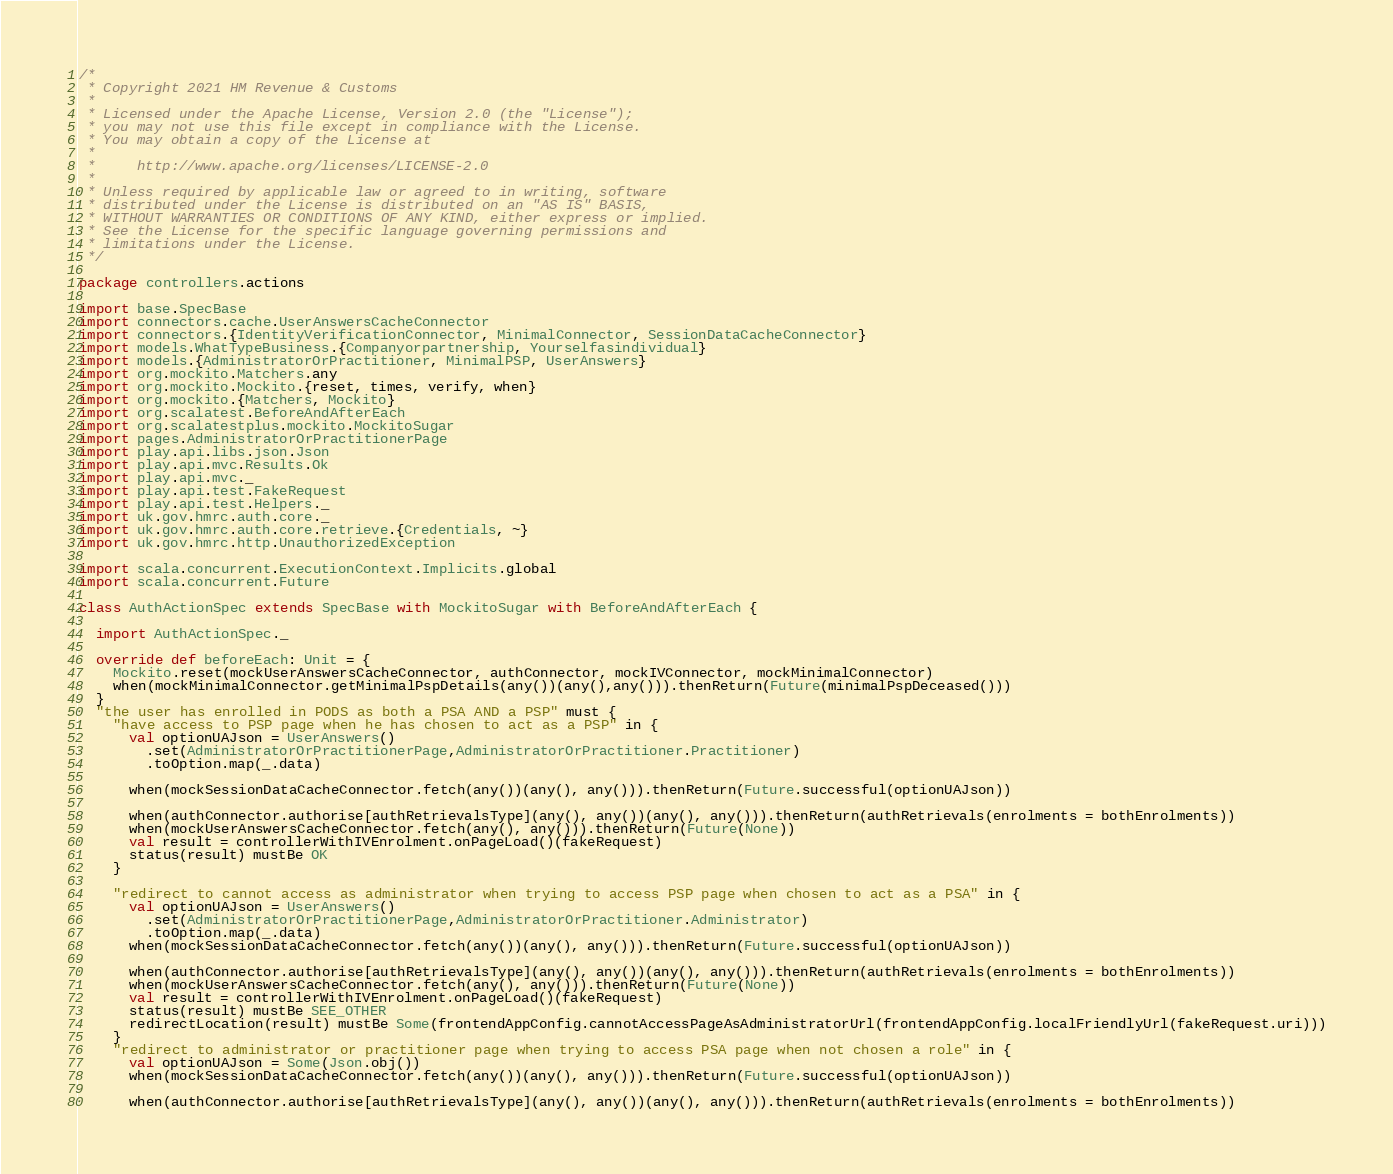<code> <loc_0><loc_0><loc_500><loc_500><_Scala_>/*
 * Copyright 2021 HM Revenue & Customs
 *
 * Licensed under the Apache License, Version 2.0 (the "License");
 * you may not use this file except in compliance with the License.
 * You may obtain a copy of the License at
 *
 *     http://www.apache.org/licenses/LICENSE-2.0
 *
 * Unless required by applicable law or agreed to in writing, software
 * distributed under the License is distributed on an "AS IS" BASIS,
 * WITHOUT WARRANTIES OR CONDITIONS OF ANY KIND, either express or implied.
 * See the License for the specific language governing permissions and
 * limitations under the License.
 */

package controllers.actions

import base.SpecBase
import connectors.cache.UserAnswersCacheConnector
import connectors.{IdentityVerificationConnector, MinimalConnector, SessionDataCacheConnector}
import models.WhatTypeBusiness.{Companyorpartnership, Yourselfasindividual}
import models.{AdministratorOrPractitioner, MinimalPSP, UserAnswers}
import org.mockito.Matchers.any
import org.mockito.Mockito.{reset, times, verify, when}
import org.mockito.{Matchers, Mockito}
import org.scalatest.BeforeAndAfterEach
import org.scalatestplus.mockito.MockitoSugar
import pages.AdministratorOrPractitionerPage
import play.api.libs.json.Json
import play.api.mvc.Results.Ok
import play.api.mvc._
import play.api.test.FakeRequest
import play.api.test.Helpers._
import uk.gov.hmrc.auth.core._
import uk.gov.hmrc.auth.core.retrieve.{Credentials, ~}
import uk.gov.hmrc.http.UnauthorizedException

import scala.concurrent.ExecutionContext.Implicits.global
import scala.concurrent.Future

class AuthActionSpec extends SpecBase with MockitoSugar with BeforeAndAfterEach {

  import AuthActionSpec._

  override def beforeEach: Unit = {
    Mockito.reset(mockUserAnswersCacheConnector, authConnector, mockIVConnector, mockMinimalConnector)
    when(mockMinimalConnector.getMinimalPspDetails(any())(any(),any())).thenReturn(Future(minimalPspDeceased()))
  }
  "the user has enrolled in PODS as both a PSA AND a PSP" must {
    "have access to PSP page when he has chosen to act as a PSP" in {
      val optionUAJson = UserAnswers()
        .set(AdministratorOrPractitionerPage,AdministratorOrPractitioner.Practitioner)
        .toOption.map(_.data)

      when(mockSessionDataCacheConnector.fetch(any())(any(), any())).thenReturn(Future.successful(optionUAJson))

      when(authConnector.authorise[authRetrievalsType](any(), any())(any(), any())).thenReturn(authRetrievals(enrolments = bothEnrolments))
      when(mockUserAnswersCacheConnector.fetch(any(), any())).thenReturn(Future(None))
      val result = controllerWithIVEnrolment.onPageLoad()(fakeRequest)
      status(result) mustBe OK
    }

    "redirect to cannot access as administrator when trying to access PSP page when chosen to act as a PSA" in {
      val optionUAJson = UserAnswers()
        .set(AdministratorOrPractitionerPage,AdministratorOrPractitioner.Administrator)
        .toOption.map(_.data)
      when(mockSessionDataCacheConnector.fetch(any())(any(), any())).thenReturn(Future.successful(optionUAJson))

      when(authConnector.authorise[authRetrievalsType](any(), any())(any(), any())).thenReturn(authRetrievals(enrolments = bothEnrolments))
      when(mockUserAnswersCacheConnector.fetch(any(), any())).thenReturn(Future(None))
      val result = controllerWithIVEnrolment.onPageLoad()(fakeRequest)
      status(result) mustBe SEE_OTHER
      redirectLocation(result) mustBe Some(frontendAppConfig.cannotAccessPageAsAdministratorUrl(frontendAppConfig.localFriendlyUrl(fakeRequest.uri)))
    }
    "redirect to administrator or practitioner page when trying to access PSA page when not chosen a role" in {
      val optionUAJson = Some(Json.obj())
      when(mockSessionDataCacheConnector.fetch(any())(any(), any())).thenReturn(Future.successful(optionUAJson))

      when(authConnector.authorise[authRetrievalsType](any(), any())(any(), any())).thenReturn(authRetrievals(enrolments = bothEnrolments))</code> 